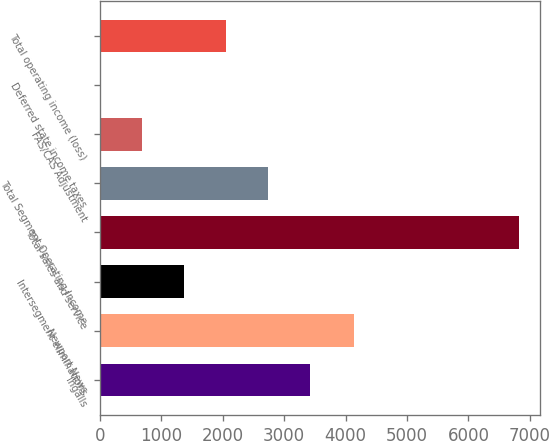Convert chart. <chart><loc_0><loc_0><loc_500><loc_500><bar_chart><fcel>Ingalls<fcel>Newport News<fcel>Intersegment eliminations<fcel>Total sales and service<fcel>Total Segment Operating Income<fcel>FAS/CAS Adjustment<fcel>Deferred state income taxes<fcel>Total operating income (loss)<nl><fcel>3413<fcel>4139<fcel>1368.8<fcel>6820<fcel>2731.6<fcel>687.4<fcel>6<fcel>2050.2<nl></chart> 